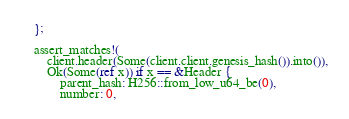Convert code to text. <code><loc_0><loc_0><loc_500><loc_500><_Rust_>	};

	assert_matches!(
		client.header(Some(client.client.genesis_hash()).into()),
		Ok(Some(ref x)) if x == &Header {
			parent_hash: H256::from_low_u64_be(0),
			number: 0,</code> 